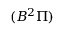<formula> <loc_0><loc_0><loc_500><loc_500>( B ^ { 2 } \Pi )</formula> 